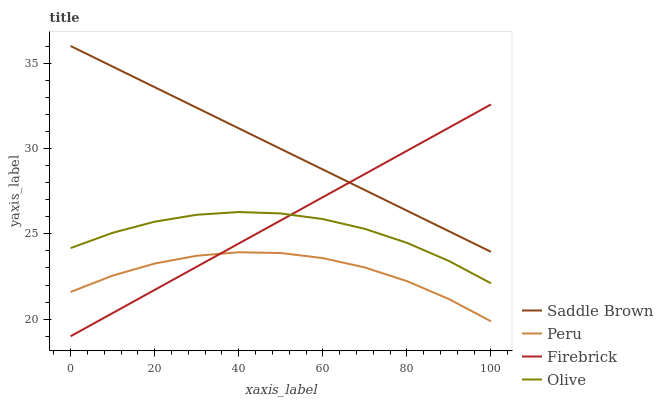Does Peru have the minimum area under the curve?
Answer yes or no. Yes. Does Saddle Brown have the maximum area under the curve?
Answer yes or no. Yes. Does Firebrick have the minimum area under the curve?
Answer yes or no. No. Does Firebrick have the maximum area under the curve?
Answer yes or no. No. Is Firebrick the smoothest?
Answer yes or no. Yes. Is Peru the roughest?
Answer yes or no. Yes. Is Saddle Brown the smoothest?
Answer yes or no. No. Is Saddle Brown the roughest?
Answer yes or no. No. Does Firebrick have the lowest value?
Answer yes or no. Yes. Does Saddle Brown have the lowest value?
Answer yes or no. No. Does Saddle Brown have the highest value?
Answer yes or no. Yes. Does Firebrick have the highest value?
Answer yes or no. No. Is Peru less than Olive?
Answer yes or no. Yes. Is Olive greater than Peru?
Answer yes or no. Yes. Does Olive intersect Firebrick?
Answer yes or no. Yes. Is Olive less than Firebrick?
Answer yes or no. No. Is Olive greater than Firebrick?
Answer yes or no. No. Does Peru intersect Olive?
Answer yes or no. No. 